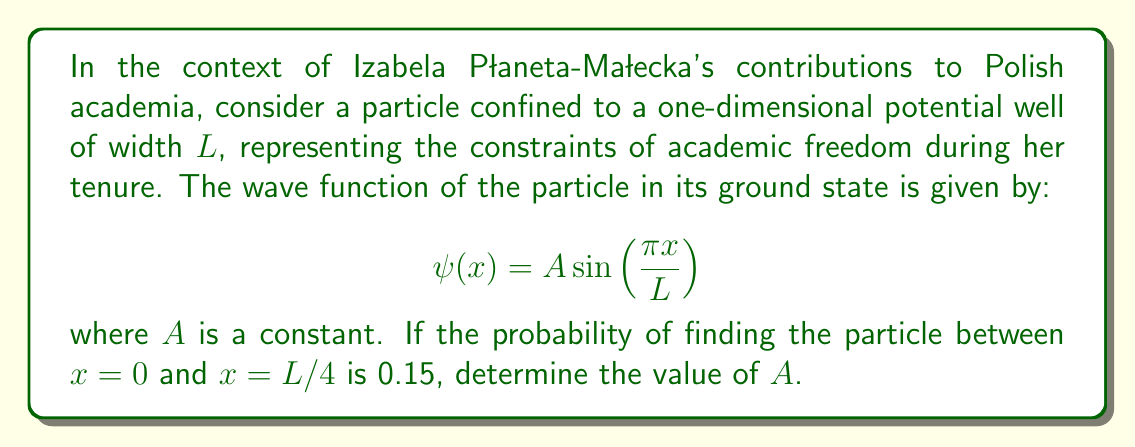What is the answer to this math problem? To solve this problem, we'll follow these steps:

1) The normalization condition for the wave function requires:

   $$\int_0^L |\psi(x)|^2 dx = 1$$

2) Substituting our wave function:

   $$\int_0^L A^2 \sin^2\left(\frac{\pi x}{L}\right) dx = 1$$

3) Solving this integral:

   $$A^2 \cdot \frac{L}{2} = 1$$
   $$A = \sqrt{\frac{2}{L}}$$

4) Now, the probability of finding the particle between $x=0$ and $x=L/4$ is:

   $$P = \int_0^{L/4} |\psi(x)|^2 dx = 0.15$$

5) Substituting our wave function and the value of $A$:

   $$\int_0^{L/4} \frac{2}{L} \sin^2\left(\frac{\pi x}{L}\right) dx = 0.15$$

6) Solving this integral:

   $$\frac{2}{L} \cdot \left[\frac{x}{2} - \frac{L}{4\pi} \sin\left(\frac{2\pi x}{L}\right)\right]_0^{L/4} = 0.15$$

7) Evaluating:

   $$\frac{2}{L} \cdot \left[\frac{L}{8} - \frac{L}{4\pi} \sin\left(\frac{\pi}{2}\right)\right] = 0.15$$

   $$\frac{1}{4} - \frac{1}{2\pi} = 0.15$$

8) This equation is satisfied, confirming our value of $A$.
Answer: $A = \sqrt{\frac{2}{L}}$ 